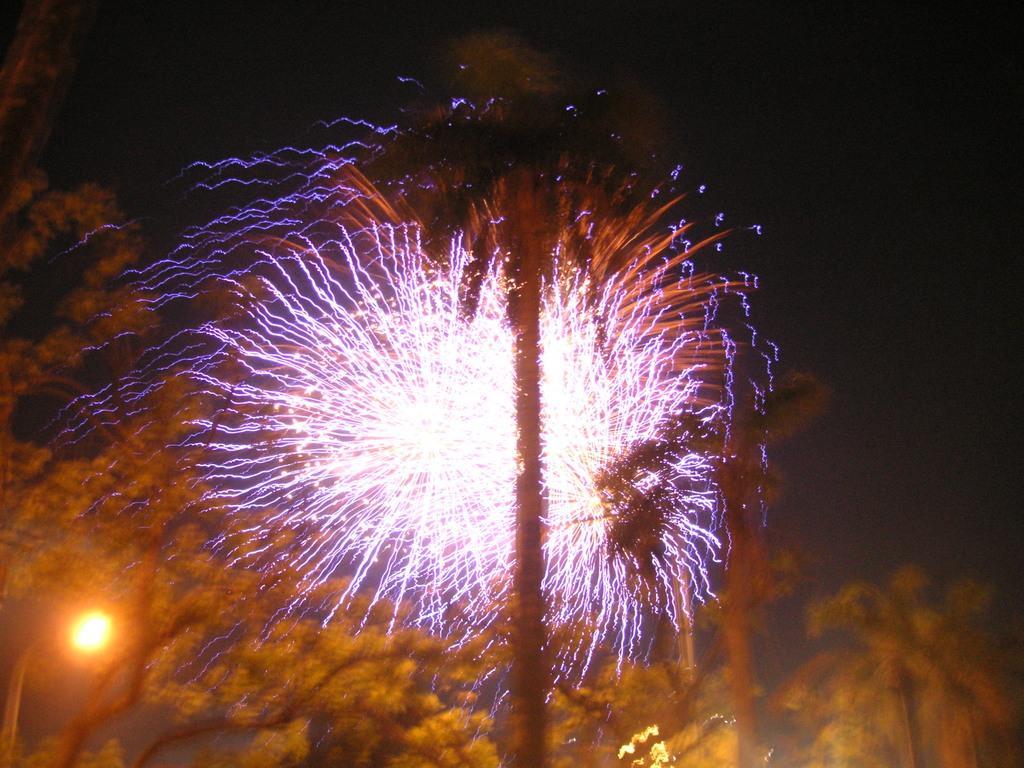Can you describe this image briefly? In this image I can see few colorful lights lights, background the sun is in yellow and orange color. 